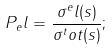Convert formula to latex. <formula><loc_0><loc_0><loc_500><loc_500>P _ { e } l = \frac { \sigma ^ { e } l ( s ) } { \sigma ^ { t } o t ( s ) } ;</formula> 